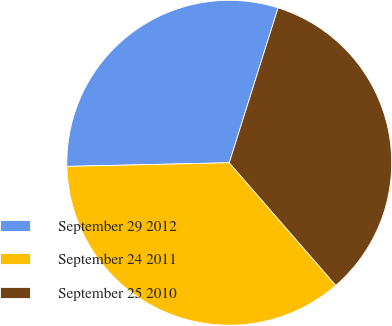<chart> <loc_0><loc_0><loc_500><loc_500><pie_chart><fcel>September 29 2012<fcel>September 24 2011<fcel>September 25 2010<nl><fcel>30.22%<fcel>36.03%<fcel>33.76%<nl></chart> 